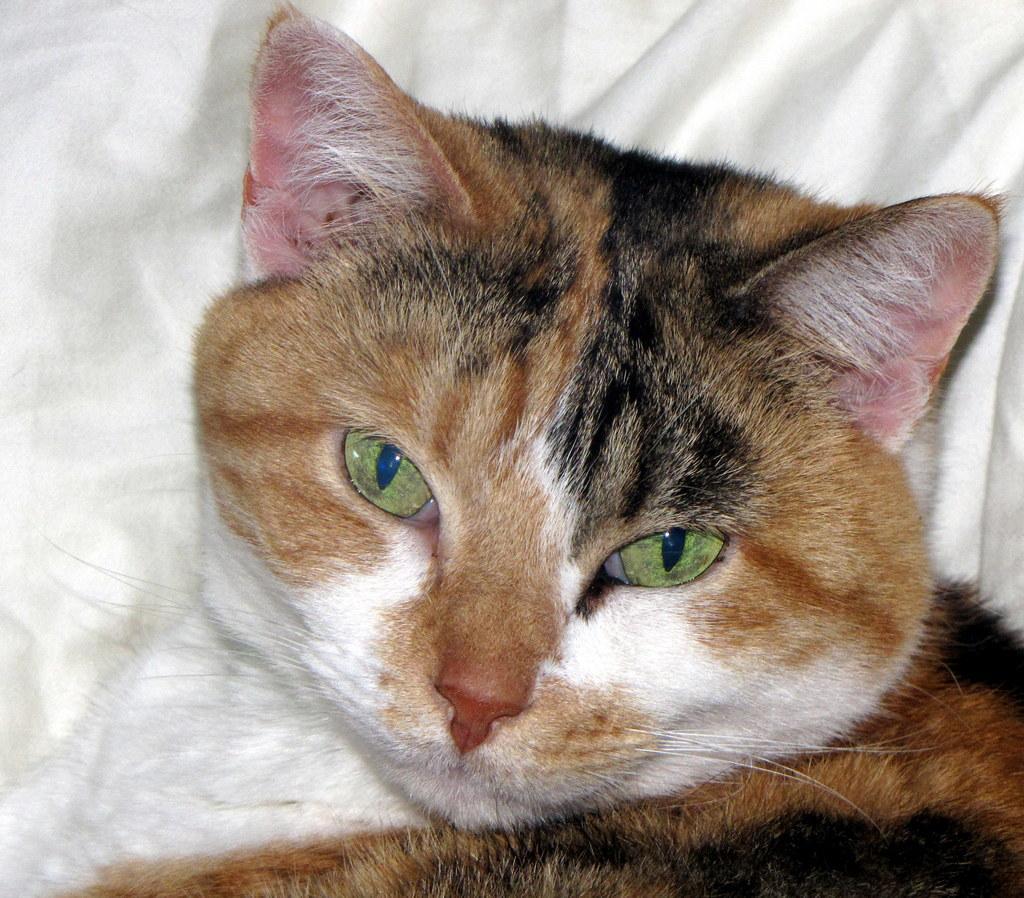How would you summarize this image in a sentence or two? In this picture, there is a cat which is in brown in color. 